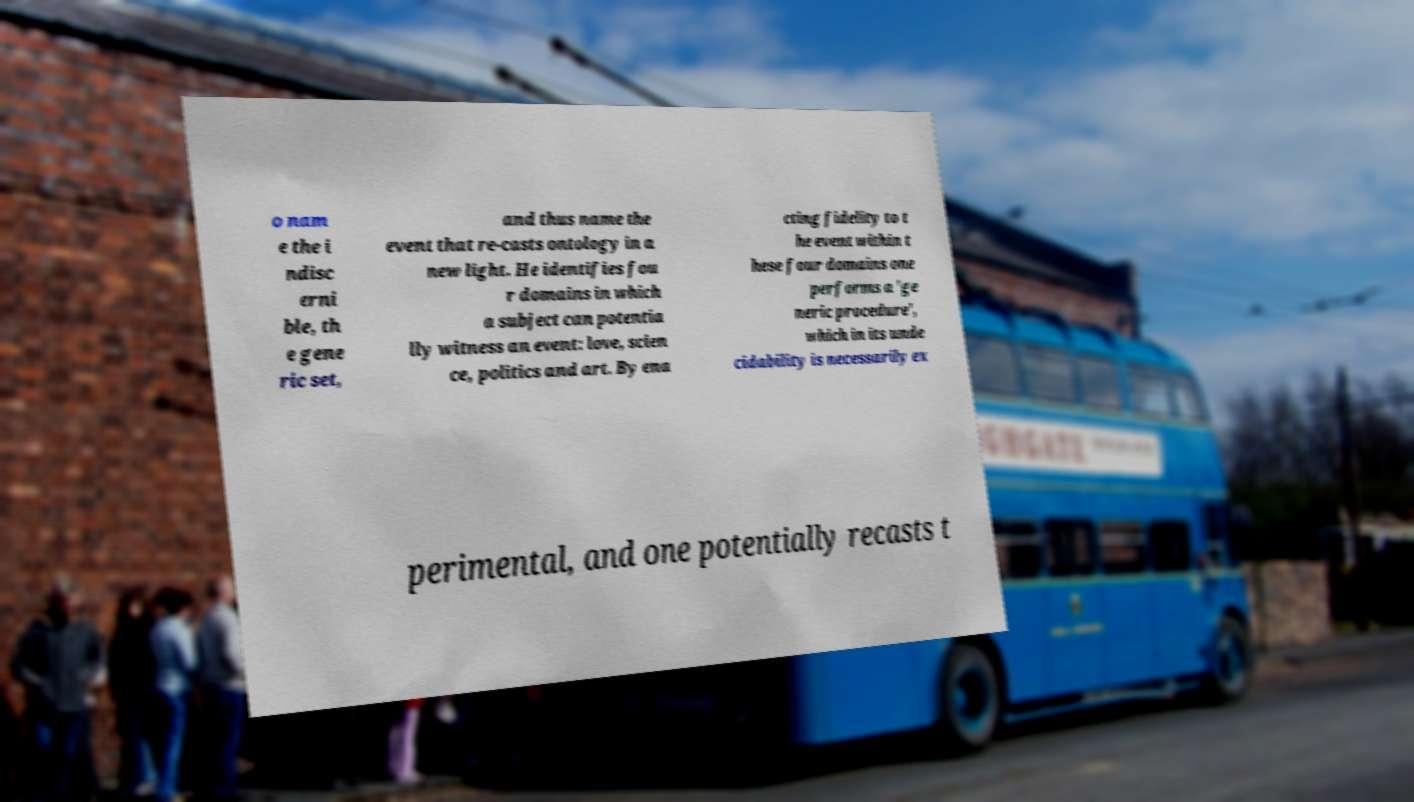There's text embedded in this image that I need extracted. Can you transcribe it verbatim? o nam e the i ndisc erni ble, th e gene ric set, and thus name the event that re-casts ontology in a new light. He identifies fou r domains in which a subject can potentia lly witness an event: love, scien ce, politics and art. By ena cting fidelity to t he event within t hese four domains one performs a 'ge neric procedure', which in its unde cidability is necessarily ex perimental, and one potentially recasts t 